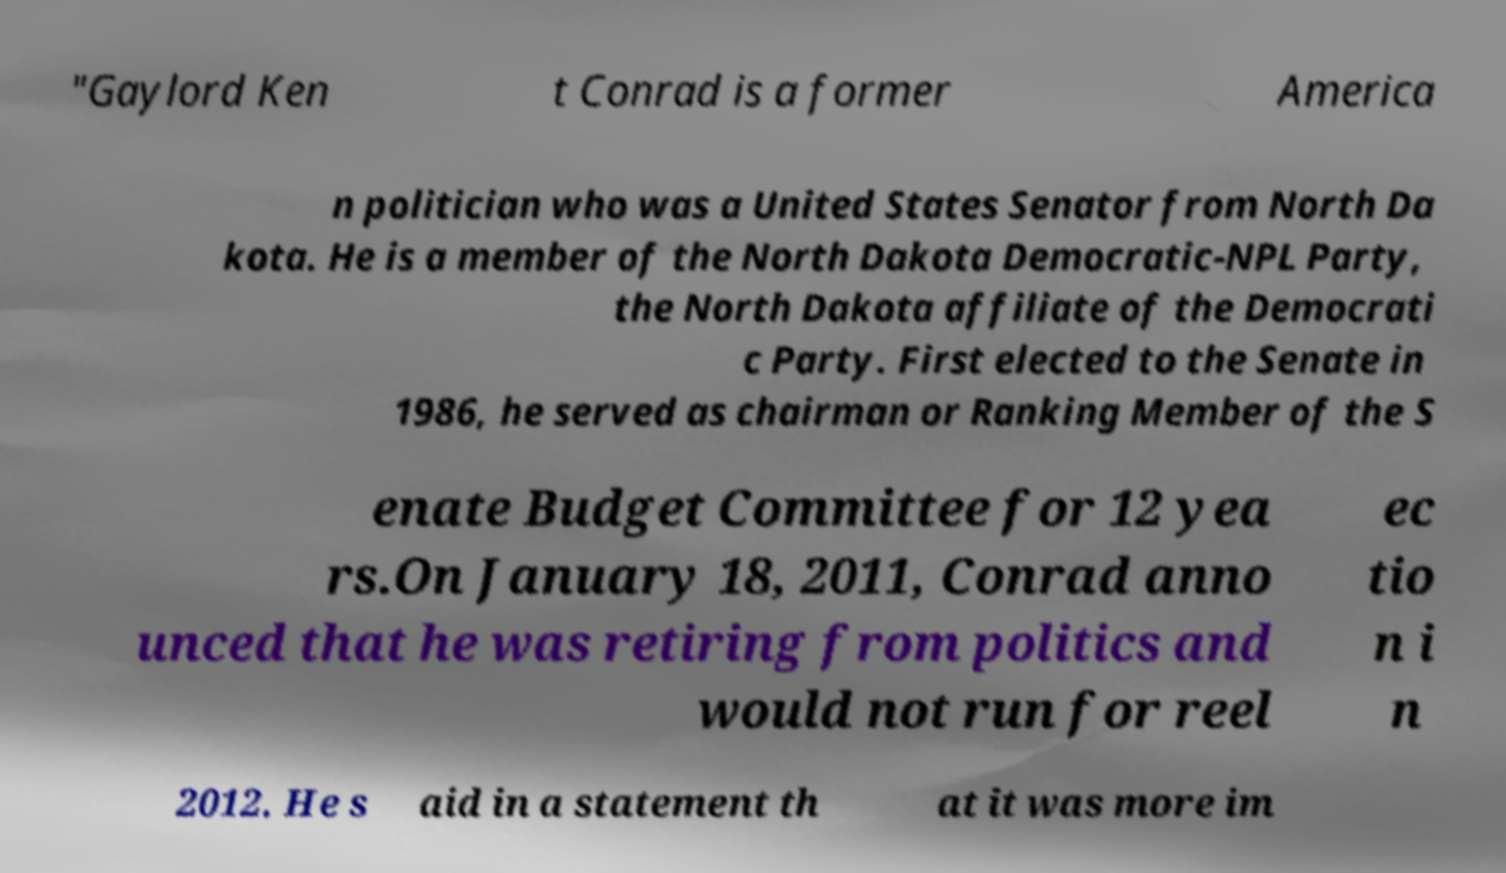I need the written content from this picture converted into text. Can you do that? "Gaylord Ken t Conrad is a former America n politician who was a United States Senator from North Da kota. He is a member of the North Dakota Democratic-NPL Party, the North Dakota affiliate of the Democrati c Party. First elected to the Senate in 1986, he served as chairman or Ranking Member of the S enate Budget Committee for 12 yea rs.On January 18, 2011, Conrad anno unced that he was retiring from politics and would not run for reel ec tio n i n 2012. He s aid in a statement th at it was more im 